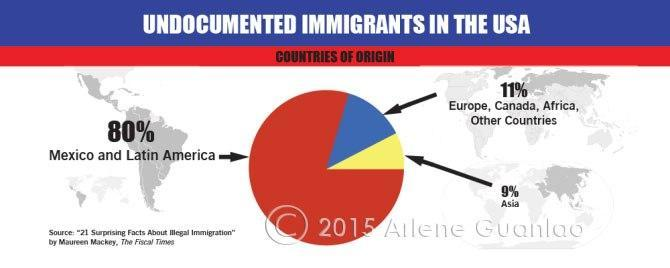Majority of undocumented immigrants in the USA belongs to which countries?
Answer the question with a short phrase. Mexico and Latin America What percent of undocumented immigrants in the USA are from Asia? 9% 